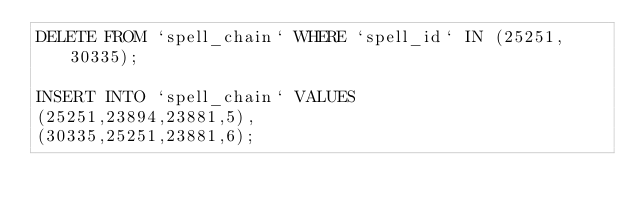<code> <loc_0><loc_0><loc_500><loc_500><_SQL_>DELETE FROM `spell_chain` WHERE `spell_id` IN (25251, 30335);

INSERT INTO `spell_chain` VALUES
(25251,23894,23881,5),
(30335,25251,23881,6);
</code> 